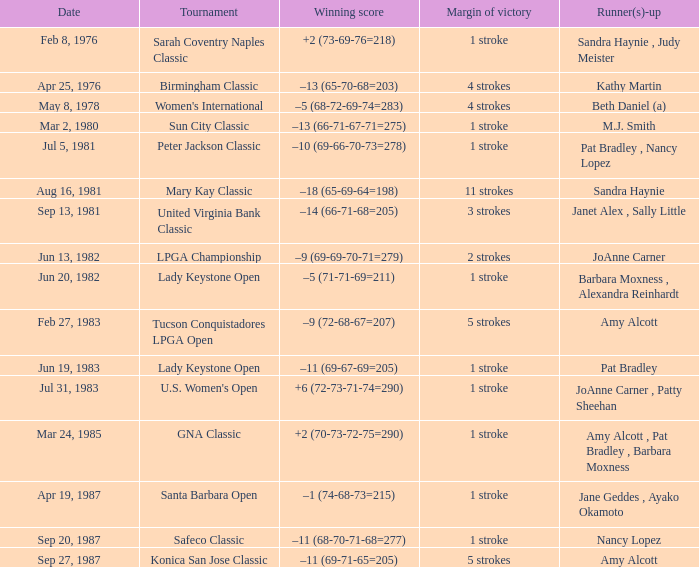What is the championship event with the winning score of -9 (69-69-70-71=279)? LPGA Championship. 